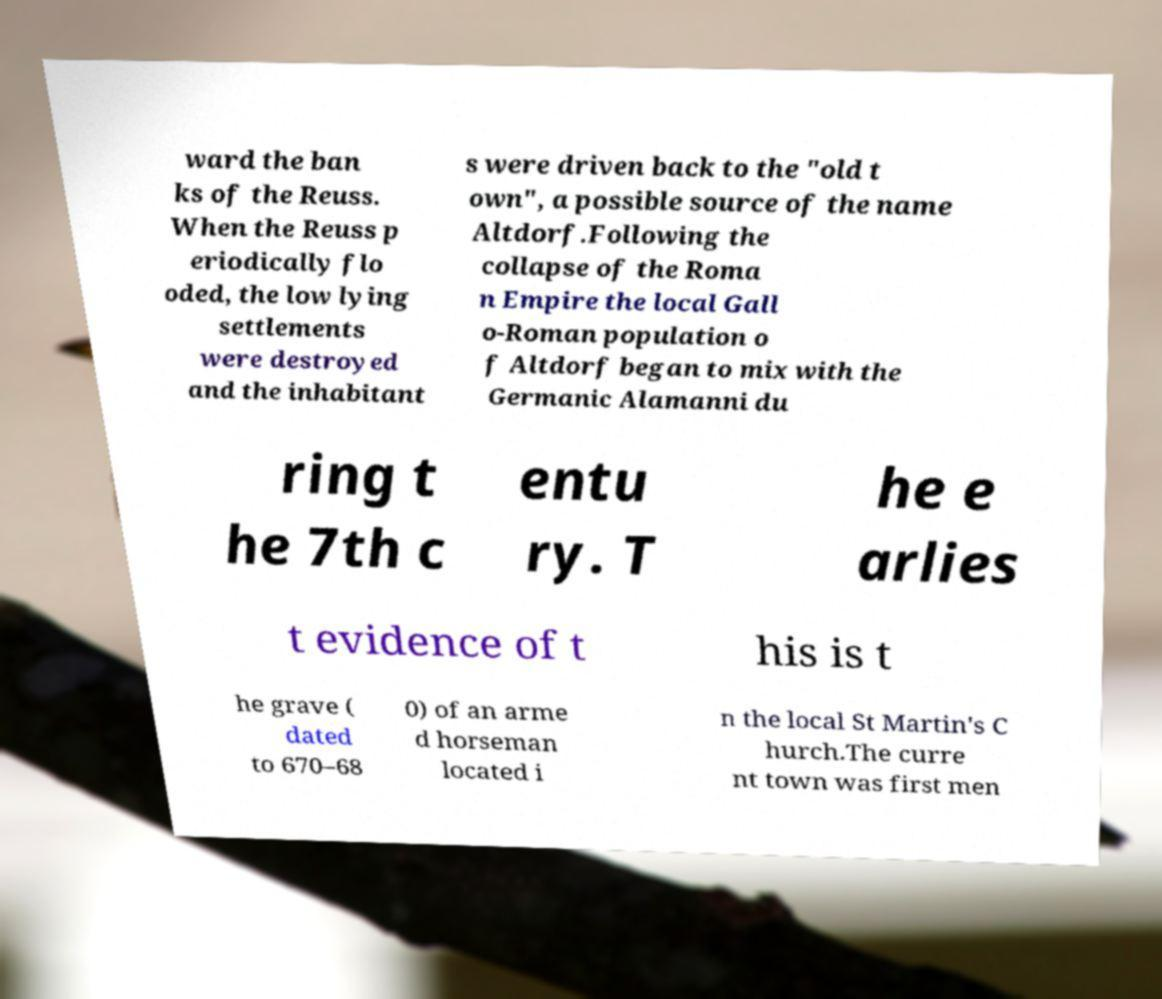What messages or text are displayed in this image? I need them in a readable, typed format. ward the ban ks of the Reuss. When the Reuss p eriodically flo oded, the low lying settlements were destroyed and the inhabitant s were driven back to the "old t own", a possible source of the name Altdorf.Following the collapse of the Roma n Empire the local Gall o-Roman population o f Altdorf began to mix with the Germanic Alamanni du ring t he 7th c entu ry. T he e arlies t evidence of t his is t he grave ( dated to 670–68 0) of an arme d horseman located i n the local St Martin's C hurch.The curre nt town was first men 